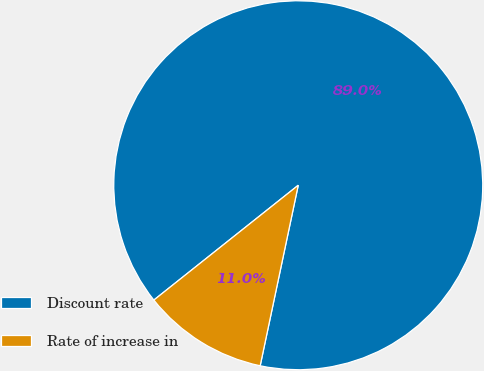<chart> <loc_0><loc_0><loc_500><loc_500><pie_chart><fcel>Discount rate<fcel>Rate of increase in<nl><fcel>89.0%<fcel>11.0%<nl></chart> 